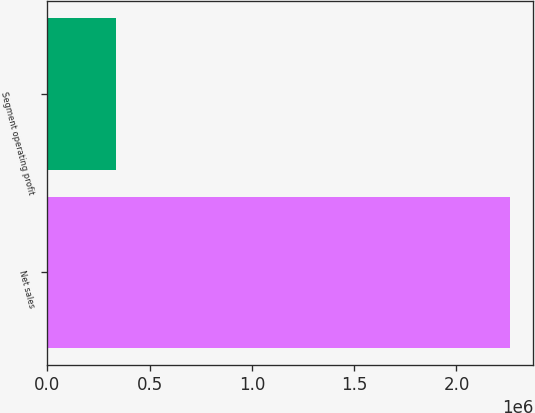Convert chart to OTSL. <chart><loc_0><loc_0><loc_500><loc_500><bar_chart><fcel>Net sales<fcel>Segment operating profit<nl><fcel>2.26117e+06<fcel>336693<nl></chart> 